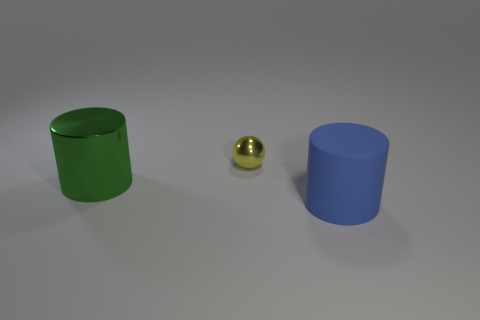Is there any other thing that is the same material as the large blue thing?
Ensure brevity in your answer.  No. There is a cylinder to the right of the big cylinder that is behind the thing in front of the green shiny thing; what is its size?
Your response must be concise. Large. What number of other objects are there of the same shape as the small shiny object?
Ensure brevity in your answer.  0. What color is the other cylinder that is the same size as the rubber cylinder?
Your response must be concise. Green. Does the cylinder to the left of the metal ball have the same size as the big matte cylinder?
Provide a short and direct response. Yes. Is the number of green cylinders that are to the right of the green shiny object the same as the number of small yellow balls?
Keep it short and to the point. No. What number of objects are tiny balls on the right side of the big metal cylinder or matte objects?
Ensure brevity in your answer.  2. What is the shape of the object that is on the left side of the large blue matte object and on the right side of the big green cylinder?
Ensure brevity in your answer.  Sphere. How many things are things in front of the green cylinder or big objects that are in front of the green cylinder?
Keep it short and to the point. 1. What number of other things are there of the same size as the yellow shiny object?
Ensure brevity in your answer.  0. 